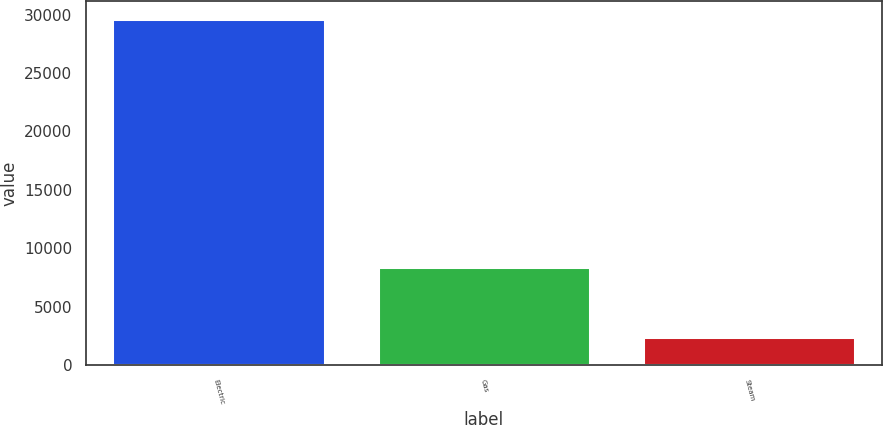<chart> <loc_0><loc_0><loc_500><loc_500><bar_chart><fcel>Electric<fcel>Gas<fcel>Steam<nl><fcel>29661<fcel>8387<fcel>2403<nl></chart> 